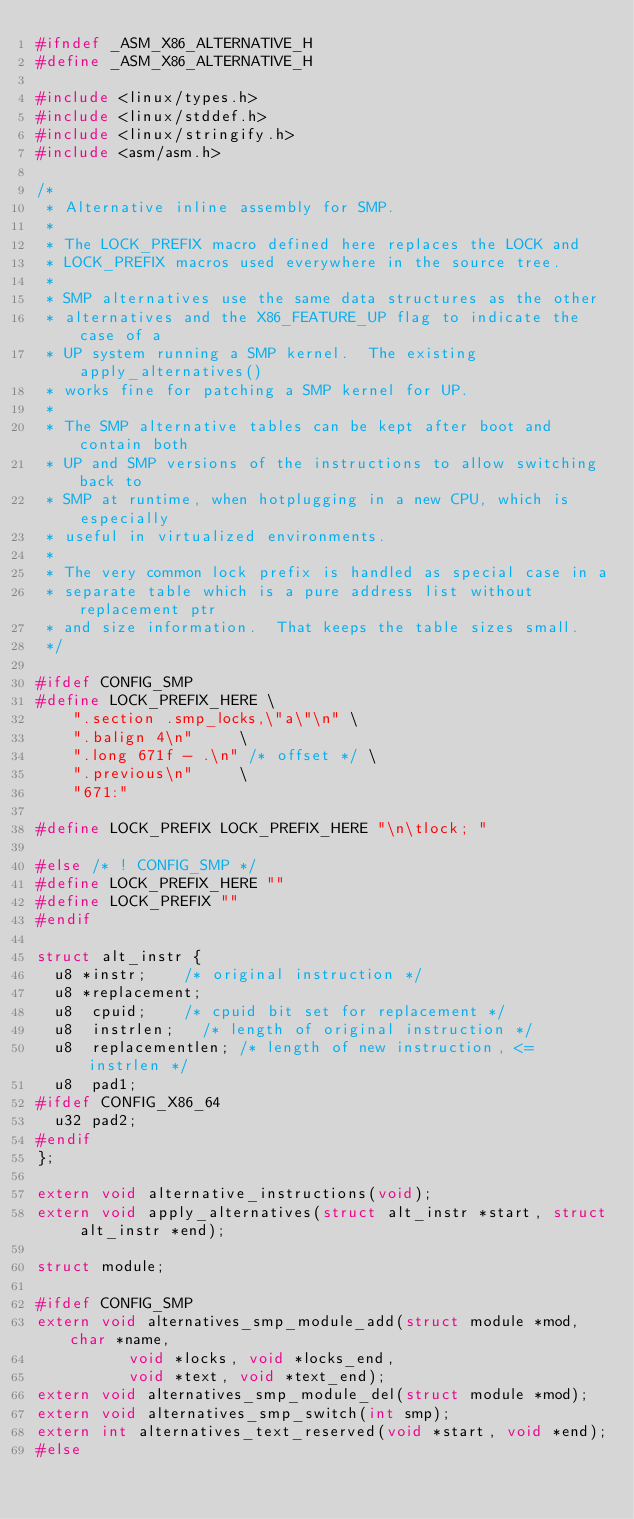<code> <loc_0><loc_0><loc_500><loc_500><_C_>#ifndef _ASM_X86_ALTERNATIVE_H
#define _ASM_X86_ALTERNATIVE_H

#include <linux/types.h>
#include <linux/stddef.h>
#include <linux/stringify.h>
#include <asm/asm.h>

/*
 * Alternative inline assembly for SMP.
 *
 * The LOCK_PREFIX macro defined here replaces the LOCK and
 * LOCK_PREFIX macros used everywhere in the source tree.
 *
 * SMP alternatives use the same data structures as the other
 * alternatives and the X86_FEATURE_UP flag to indicate the case of a
 * UP system running a SMP kernel.  The existing apply_alternatives()
 * works fine for patching a SMP kernel for UP.
 *
 * The SMP alternative tables can be kept after boot and contain both
 * UP and SMP versions of the instructions to allow switching back to
 * SMP at runtime, when hotplugging in a new CPU, which is especially
 * useful in virtualized environments.
 *
 * The very common lock prefix is handled as special case in a
 * separate table which is a pure address list without replacement ptr
 * and size information.  That keeps the table sizes small.
 */

#ifdef CONFIG_SMP
#define LOCK_PREFIX_HERE \
		".section .smp_locks,\"a\"\n"	\
		".balign 4\n"			\
		".long 671f - .\n" /* offset */	\
		".previous\n"			\
		"671:"

#define LOCK_PREFIX LOCK_PREFIX_HERE "\n\tlock; "

#else /* ! CONFIG_SMP */
#define LOCK_PREFIX_HERE ""
#define LOCK_PREFIX ""
#endif

struct alt_instr {
	u8 *instr;		/* original instruction */
	u8 *replacement;
	u8  cpuid;		/* cpuid bit set for replacement */
	u8  instrlen;		/* length of original instruction */
	u8  replacementlen;	/* length of new instruction, <= instrlen */
	u8  pad1;
#ifdef CONFIG_X86_64
	u32 pad2;
#endif
};

extern void alternative_instructions(void);
extern void apply_alternatives(struct alt_instr *start, struct alt_instr *end);

struct module;

#ifdef CONFIG_SMP
extern void alternatives_smp_module_add(struct module *mod, char *name,
					void *locks, void *locks_end,
					void *text, void *text_end);
extern void alternatives_smp_module_del(struct module *mod);
extern void alternatives_smp_switch(int smp);
extern int alternatives_text_reserved(void *start, void *end);
#else</code> 